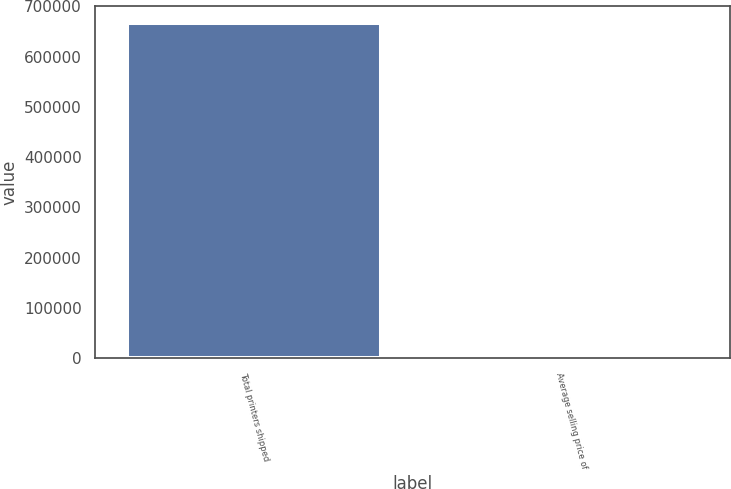<chart> <loc_0><loc_0><loc_500><loc_500><bar_chart><fcel>Total printers shipped<fcel>Average selling price of<nl><fcel>667044<fcel>646<nl></chart> 